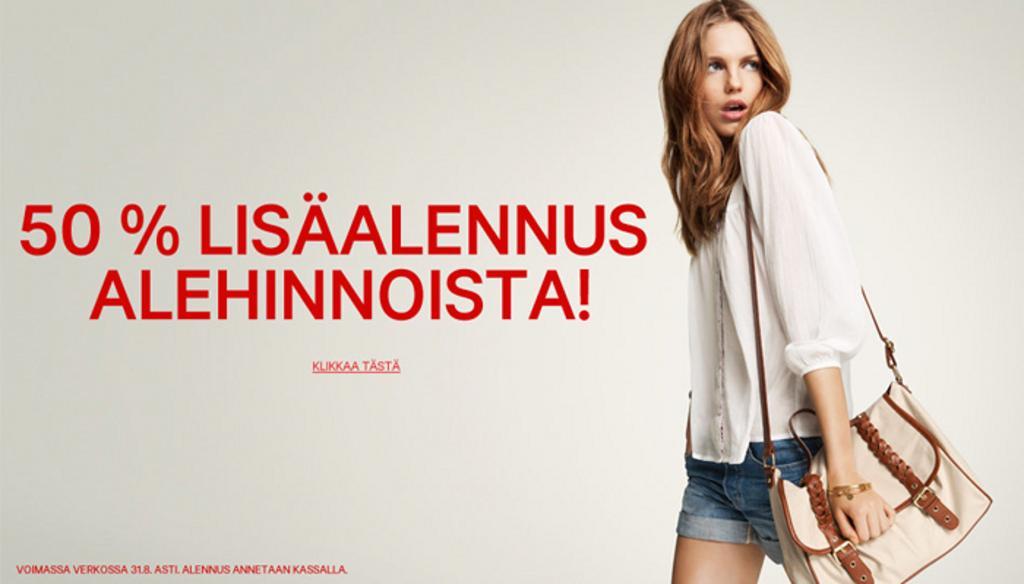How would you summarize this image in a sentence or two? in this picture on the right there is a woman wearing white color shirt, a sling bag and walking. On the left we can see a wall on which some text is printed. 